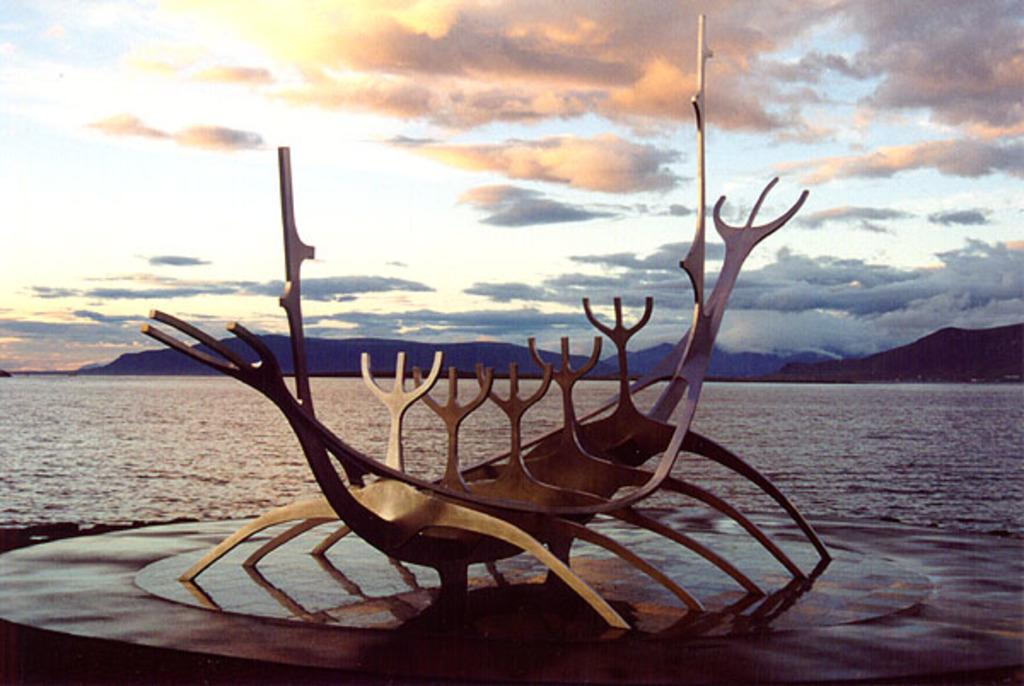What is the main subject of the image? There is a sculpture in the image. What can be seen in the foreground of the image? Water is visible in the image. What is visible in the background of the image? There are hills in the background of the image. What is visible above the hills in the image? The sky is visible in the image. Can you tell me how many maids are standing next to the sculpture in the image? There are no maids present in the image; it features a sculpture, water, hills, and the sky. What type of throat condition can be seen in the image? There is no throat condition visible in the image; it features a sculpture, water, hills, and the sky. 